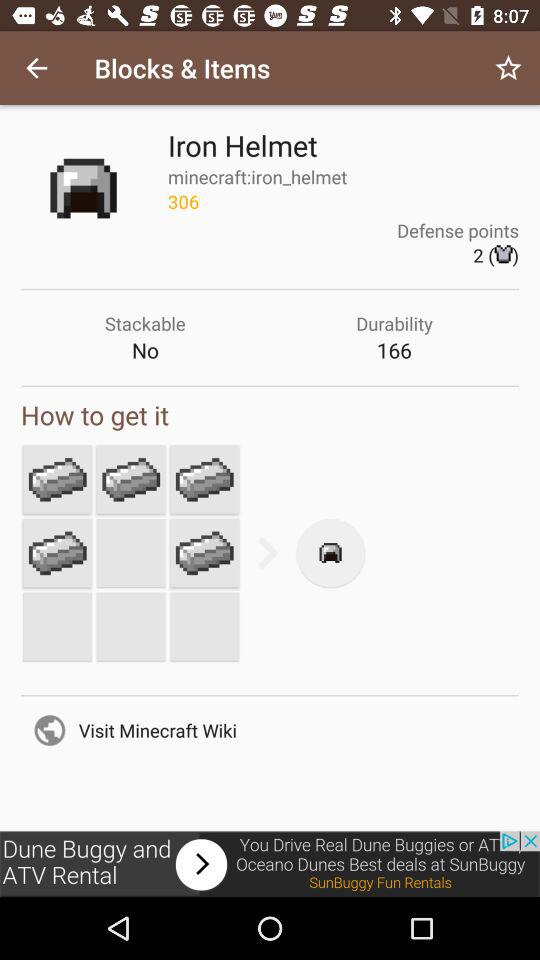What's the durability of the "Iron Helmet"? The durability of the "Iron Helmet" is 166. 